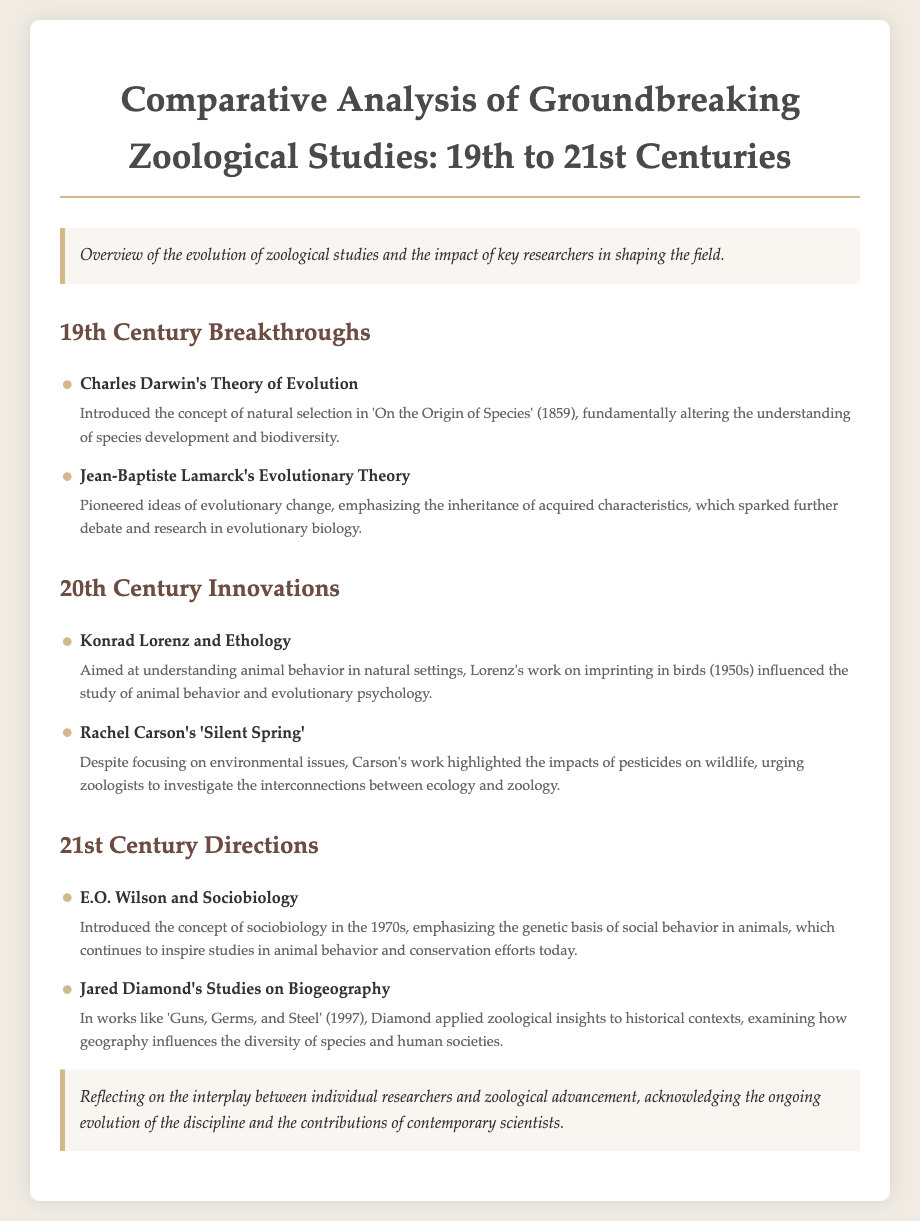What groundbreaking concept did Charles Darwin introduce? Charles Darwin introduced the concept of natural selection, which is a central idea in his work 'On the Origin of Species'.
Answer: natural selection What decade did Konrad Lorenz conduct his significant research? Konrad Lorenz's important research on animal behavior, particularly imprinting, took place in the 1950s.
Answer: 1950s Which study emphasized the genetic basis of social behavior? E.O. Wilson introduced the concept of sociobiology, which focuses on the genetic basis of social behavior in animals.
Answer: sociobiology What year was "On the Origin of Species" published? The publication year for Darwin's influential book 'On the Origin of Species' is 1859.
Answer: 1859 What work is associated with Rachel Carson? Rachel Carson is best known for her book 'Silent Spring', which addressed environmental issues and their impact on wildlife.
Answer: Silent Spring Which researcher is noted for their studies in biogeography? Jared Diamond is recognized for his studies on biogeography, particularly in his work 'Guns, Germs, and Steel'.
Answer: Jared Diamond How did Jean-Baptiste Lamarck contribute to evolutionary theory? Jean-Baptiste Lamarck pioneered ideas about the inheritance of acquired characteristics, contributing to the debate in evolutionary biology.
Answer: inheritance of acquired characteristics What is a primary focus of ethology? Ethology primarily focuses on understanding animal behavior in natural settings, as exemplified by Konrad Lorenz's studies.
Answer: animal behavior What is highlighted in the conclusion of the document? The conclusion reflects on the interplay between individual researchers and the advancement of zoological science.
Answer: interplay between individual researchers and zoological advancement 